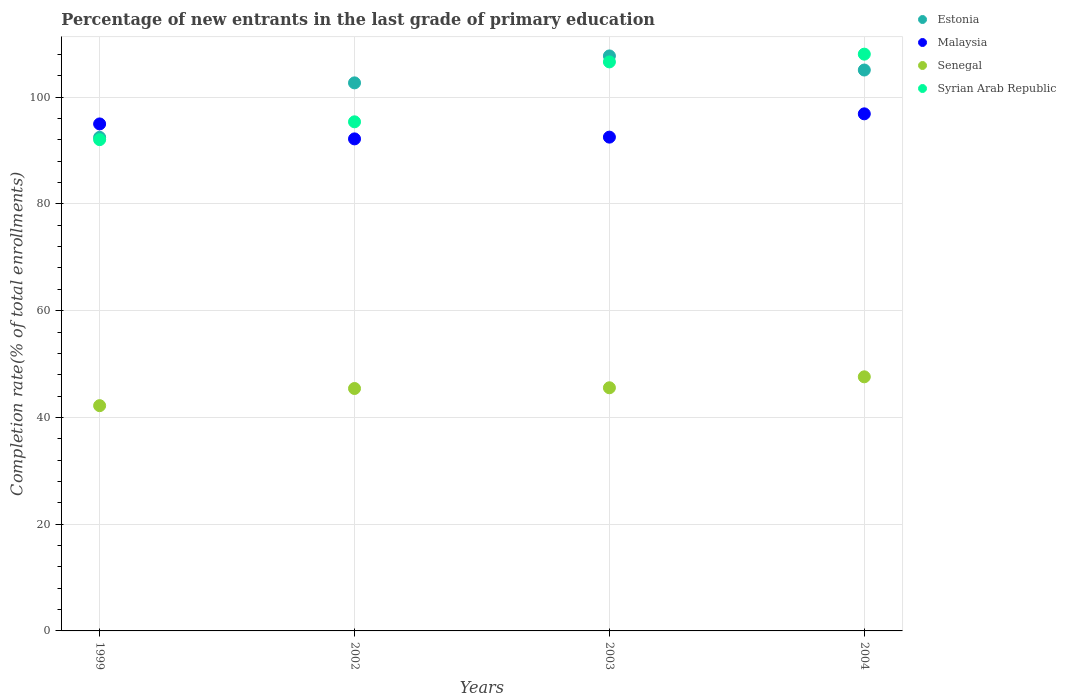Is the number of dotlines equal to the number of legend labels?
Ensure brevity in your answer.  Yes. What is the percentage of new entrants in Senegal in 2004?
Keep it short and to the point. 47.61. Across all years, what is the maximum percentage of new entrants in Estonia?
Your answer should be compact. 107.72. Across all years, what is the minimum percentage of new entrants in Senegal?
Offer a terse response. 42.2. In which year was the percentage of new entrants in Syrian Arab Republic maximum?
Give a very brief answer. 2004. What is the total percentage of new entrants in Syrian Arab Republic in the graph?
Provide a succinct answer. 402.07. What is the difference between the percentage of new entrants in Malaysia in 2002 and that in 2003?
Ensure brevity in your answer.  -0.33. What is the difference between the percentage of new entrants in Malaysia in 2002 and the percentage of new entrants in Estonia in 1999?
Offer a terse response. -0.29. What is the average percentage of new entrants in Senegal per year?
Provide a short and direct response. 45.19. In the year 2003, what is the difference between the percentage of new entrants in Senegal and percentage of new entrants in Malaysia?
Your answer should be compact. -46.95. What is the ratio of the percentage of new entrants in Estonia in 1999 to that in 2002?
Offer a terse response. 0.9. What is the difference between the highest and the second highest percentage of new entrants in Syrian Arab Republic?
Your response must be concise. 1.45. What is the difference between the highest and the lowest percentage of new entrants in Senegal?
Your response must be concise. 5.4. In how many years, is the percentage of new entrants in Senegal greater than the average percentage of new entrants in Senegal taken over all years?
Make the answer very short. 3. Is it the case that in every year, the sum of the percentage of new entrants in Syrian Arab Republic and percentage of new entrants in Malaysia  is greater than the sum of percentage of new entrants in Senegal and percentage of new entrants in Estonia?
Your answer should be compact. No. Is it the case that in every year, the sum of the percentage of new entrants in Malaysia and percentage of new entrants in Syrian Arab Republic  is greater than the percentage of new entrants in Estonia?
Your answer should be very brief. Yes. How many dotlines are there?
Your answer should be very brief. 4. What is the difference between two consecutive major ticks on the Y-axis?
Offer a very short reply. 20. Are the values on the major ticks of Y-axis written in scientific E-notation?
Ensure brevity in your answer.  No. Where does the legend appear in the graph?
Offer a very short reply. Top right. How many legend labels are there?
Provide a short and direct response. 4. What is the title of the graph?
Your answer should be compact. Percentage of new entrants in the last grade of primary education. What is the label or title of the Y-axis?
Your answer should be very brief. Completion rate(% of total enrollments). What is the Completion rate(% of total enrollments) in Estonia in 1999?
Keep it short and to the point. 92.47. What is the Completion rate(% of total enrollments) of Malaysia in 1999?
Provide a short and direct response. 94.98. What is the Completion rate(% of total enrollments) of Senegal in 1999?
Offer a very short reply. 42.2. What is the Completion rate(% of total enrollments) in Syrian Arab Republic in 1999?
Your response must be concise. 92.04. What is the Completion rate(% of total enrollments) in Estonia in 2002?
Give a very brief answer. 102.67. What is the Completion rate(% of total enrollments) of Malaysia in 2002?
Keep it short and to the point. 92.18. What is the Completion rate(% of total enrollments) of Senegal in 2002?
Your answer should be very brief. 45.42. What is the Completion rate(% of total enrollments) of Syrian Arab Republic in 2002?
Provide a succinct answer. 95.38. What is the Completion rate(% of total enrollments) of Estonia in 2003?
Provide a succinct answer. 107.72. What is the Completion rate(% of total enrollments) in Malaysia in 2003?
Provide a succinct answer. 92.51. What is the Completion rate(% of total enrollments) of Senegal in 2003?
Ensure brevity in your answer.  45.55. What is the Completion rate(% of total enrollments) in Syrian Arab Republic in 2003?
Your answer should be compact. 106.6. What is the Completion rate(% of total enrollments) of Estonia in 2004?
Make the answer very short. 105.08. What is the Completion rate(% of total enrollments) in Malaysia in 2004?
Offer a very short reply. 96.87. What is the Completion rate(% of total enrollments) of Senegal in 2004?
Your answer should be very brief. 47.61. What is the Completion rate(% of total enrollments) in Syrian Arab Republic in 2004?
Offer a very short reply. 108.05. Across all years, what is the maximum Completion rate(% of total enrollments) in Estonia?
Ensure brevity in your answer.  107.72. Across all years, what is the maximum Completion rate(% of total enrollments) of Malaysia?
Ensure brevity in your answer.  96.87. Across all years, what is the maximum Completion rate(% of total enrollments) of Senegal?
Give a very brief answer. 47.61. Across all years, what is the maximum Completion rate(% of total enrollments) of Syrian Arab Republic?
Keep it short and to the point. 108.05. Across all years, what is the minimum Completion rate(% of total enrollments) of Estonia?
Give a very brief answer. 92.47. Across all years, what is the minimum Completion rate(% of total enrollments) in Malaysia?
Offer a very short reply. 92.18. Across all years, what is the minimum Completion rate(% of total enrollments) in Senegal?
Your answer should be compact. 42.2. Across all years, what is the minimum Completion rate(% of total enrollments) in Syrian Arab Republic?
Make the answer very short. 92.04. What is the total Completion rate(% of total enrollments) of Estonia in the graph?
Keep it short and to the point. 407.94. What is the total Completion rate(% of total enrollments) in Malaysia in the graph?
Offer a very short reply. 376.54. What is the total Completion rate(% of total enrollments) in Senegal in the graph?
Offer a very short reply. 180.77. What is the total Completion rate(% of total enrollments) of Syrian Arab Republic in the graph?
Your answer should be very brief. 402.07. What is the difference between the Completion rate(% of total enrollments) of Estonia in 1999 and that in 2002?
Ensure brevity in your answer.  -10.21. What is the difference between the Completion rate(% of total enrollments) of Malaysia in 1999 and that in 2002?
Keep it short and to the point. 2.8. What is the difference between the Completion rate(% of total enrollments) in Senegal in 1999 and that in 2002?
Offer a very short reply. -3.22. What is the difference between the Completion rate(% of total enrollments) of Syrian Arab Republic in 1999 and that in 2002?
Give a very brief answer. -3.34. What is the difference between the Completion rate(% of total enrollments) in Estonia in 1999 and that in 2003?
Your answer should be compact. -15.25. What is the difference between the Completion rate(% of total enrollments) of Malaysia in 1999 and that in 2003?
Your answer should be very brief. 2.47. What is the difference between the Completion rate(% of total enrollments) in Senegal in 1999 and that in 2003?
Your response must be concise. -3.35. What is the difference between the Completion rate(% of total enrollments) in Syrian Arab Republic in 1999 and that in 2003?
Provide a succinct answer. -14.56. What is the difference between the Completion rate(% of total enrollments) of Estonia in 1999 and that in 2004?
Your response must be concise. -12.61. What is the difference between the Completion rate(% of total enrollments) in Malaysia in 1999 and that in 2004?
Provide a short and direct response. -1.89. What is the difference between the Completion rate(% of total enrollments) in Senegal in 1999 and that in 2004?
Your answer should be very brief. -5.4. What is the difference between the Completion rate(% of total enrollments) in Syrian Arab Republic in 1999 and that in 2004?
Your answer should be very brief. -16.02. What is the difference between the Completion rate(% of total enrollments) in Estonia in 2002 and that in 2003?
Provide a short and direct response. -5.05. What is the difference between the Completion rate(% of total enrollments) in Malaysia in 2002 and that in 2003?
Make the answer very short. -0.33. What is the difference between the Completion rate(% of total enrollments) in Senegal in 2002 and that in 2003?
Keep it short and to the point. -0.14. What is the difference between the Completion rate(% of total enrollments) of Syrian Arab Republic in 2002 and that in 2003?
Keep it short and to the point. -11.22. What is the difference between the Completion rate(% of total enrollments) of Estonia in 2002 and that in 2004?
Your response must be concise. -2.41. What is the difference between the Completion rate(% of total enrollments) of Malaysia in 2002 and that in 2004?
Provide a succinct answer. -4.69. What is the difference between the Completion rate(% of total enrollments) of Senegal in 2002 and that in 2004?
Keep it short and to the point. -2.19. What is the difference between the Completion rate(% of total enrollments) in Syrian Arab Republic in 2002 and that in 2004?
Make the answer very short. -12.68. What is the difference between the Completion rate(% of total enrollments) of Estonia in 2003 and that in 2004?
Give a very brief answer. 2.64. What is the difference between the Completion rate(% of total enrollments) of Malaysia in 2003 and that in 2004?
Provide a short and direct response. -4.36. What is the difference between the Completion rate(% of total enrollments) in Senegal in 2003 and that in 2004?
Make the answer very short. -2.05. What is the difference between the Completion rate(% of total enrollments) in Syrian Arab Republic in 2003 and that in 2004?
Your answer should be compact. -1.45. What is the difference between the Completion rate(% of total enrollments) of Estonia in 1999 and the Completion rate(% of total enrollments) of Malaysia in 2002?
Your response must be concise. 0.29. What is the difference between the Completion rate(% of total enrollments) in Estonia in 1999 and the Completion rate(% of total enrollments) in Senegal in 2002?
Your answer should be compact. 47.05. What is the difference between the Completion rate(% of total enrollments) of Estonia in 1999 and the Completion rate(% of total enrollments) of Syrian Arab Republic in 2002?
Offer a terse response. -2.91. What is the difference between the Completion rate(% of total enrollments) of Malaysia in 1999 and the Completion rate(% of total enrollments) of Senegal in 2002?
Make the answer very short. 49.57. What is the difference between the Completion rate(% of total enrollments) in Malaysia in 1999 and the Completion rate(% of total enrollments) in Syrian Arab Republic in 2002?
Keep it short and to the point. -0.4. What is the difference between the Completion rate(% of total enrollments) of Senegal in 1999 and the Completion rate(% of total enrollments) of Syrian Arab Republic in 2002?
Provide a succinct answer. -53.18. What is the difference between the Completion rate(% of total enrollments) in Estonia in 1999 and the Completion rate(% of total enrollments) in Malaysia in 2003?
Offer a terse response. -0.04. What is the difference between the Completion rate(% of total enrollments) of Estonia in 1999 and the Completion rate(% of total enrollments) of Senegal in 2003?
Your answer should be compact. 46.91. What is the difference between the Completion rate(% of total enrollments) of Estonia in 1999 and the Completion rate(% of total enrollments) of Syrian Arab Republic in 2003?
Offer a very short reply. -14.13. What is the difference between the Completion rate(% of total enrollments) in Malaysia in 1999 and the Completion rate(% of total enrollments) in Senegal in 2003?
Ensure brevity in your answer.  49.43. What is the difference between the Completion rate(% of total enrollments) of Malaysia in 1999 and the Completion rate(% of total enrollments) of Syrian Arab Republic in 2003?
Provide a succinct answer. -11.62. What is the difference between the Completion rate(% of total enrollments) of Senegal in 1999 and the Completion rate(% of total enrollments) of Syrian Arab Republic in 2003?
Ensure brevity in your answer.  -64.4. What is the difference between the Completion rate(% of total enrollments) of Estonia in 1999 and the Completion rate(% of total enrollments) of Malaysia in 2004?
Keep it short and to the point. -4.4. What is the difference between the Completion rate(% of total enrollments) of Estonia in 1999 and the Completion rate(% of total enrollments) of Senegal in 2004?
Give a very brief answer. 44.86. What is the difference between the Completion rate(% of total enrollments) in Estonia in 1999 and the Completion rate(% of total enrollments) in Syrian Arab Republic in 2004?
Your response must be concise. -15.59. What is the difference between the Completion rate(% of total enrollments) of Malaysia in 1999 and the Completion rate(% of total enrollments) of Senegal in 2004?
Offer a terse response. 47.38. What is the difference between the Completion rate(% of total enrollments) of Malaysia in 1999 and the Completion rate(% of total enrollments) of Syrian Arab Republic in 2004?
Your answer should be compact. -13.07. What is the difference between the Completion rate(% of total enrollments) of Senegal in 1999 and the Completion rate(% of total enrollments) of Syrian Arab Republic in 2004?
Ensure brevity in your answer.  -65.85. What is the difference between the Completion rate(% of total enrollments) of Estonia in 2002 and the Completion rate(% of total enrollments) of Malaysia in 2003?
Your response must be concise. 10.17. What is the difference between the Completion rate(% of total enrollments) in Estonia in 2002 and the Completion rate(% of total enrollments) in Senegal in 2003?
Your response must be concise. 57.12. What is the difference between the Completion rate(% of total enrollments) of Estonia in 2002 and the Completion rate(% of total enrollments) of Syrian Arab Republic in 2003?
Ensure brevity in your answer.  -3.93. What is the difference between the Completion rate(% of total enrollments) of Malaysia in 2002 and the Completion rate(% of total enrollments) of Senegal in 2003?
Your answer should be very brief. 46.63. What is the difference between the Completion rate(% of total enrollments) of Malaysia in 2002 and the Completion rate(% of total enrollments) of Syrian Arab Republic in 2003?
Ensure brevity in your answer.  -14.42. What is the difference between the Completion rate(% of total enrollments) in Senegal in 2002 and the Completion rate(% of total enrollments) in Syrian Arab Republic in 2003?
Keep it short and to the point. -61.18. What is the difference between the Completion rate(% of total enrollments) of Estonia in 2002 and the Completion rate(% of total enrollments) of Malaysia in 2004?
Provide a short and direct response. 5.8. What is the difference between the Completion rate(% of total enrollments) of Estonia in 2002 and the Completion rate(% of total enrollments) of Senegal in 2004?
Your answer should be compact. 55.07. What is the difference between the Completion rate(% of total enrollments) in Estonia in 2002 and the Completion rate(% of total enrollments) in Syrian Arab Republic in 2004?
Your answer should be compact. -5.38. What is the difference between the Completion rate(% of total enrollments) of Malaysia in 2002 and the Completion rate(% of total enrollments) of Senegal in 2004?
Give a very brief answer. 44.57. What is the difference between the Completion rate(% of total enrollments) in Malaysia in 2002 and the Completion rate(% of total enrollments) in Syrian Arab Republic in 2004?
Offer a very short reply. -15.87. What is the difference between the Completion rate(% of total enrollments) of Senegal in 2002 and the Completion rate(% of total enrollments) of Syrian Arab Republic in 2004?
Keep it short and to the point. -62.64. What is the difference between the Completion rate(% of total enrollments) of Estonia in 2003 and the Completion rate(% of total enrollments) of Malaysia in 2004?
Your answer should be very brief. 10.85. What is the difference between the Completion rate(% of total enrollments) in Estonia in 2003 and the Completion rate(% of total enrollments) in Senegal in 2004?
Your answer should be compact. 60.11. What is the difference between the Completion rate(% of total enrollments) in Estonia in 2003 and the Completion rate(% of total enrollments) in Syrian Arab Republic in 2004?
Provide a short and direct response. -0.33. What is the difference between the Completion rate(% of total enrollments) of Malaysia in 2003 and the Completion rate(% of total enrollments) of Senegal in 2004?
Give a very brief answer. 44.9. What is the difference between the Completion rate(% of total enrollments) of Malaysia in 2003 and the Completion rate(% of total enrollments) of Syrian Arab Republic in 2004?
Your answer should be very brief. -15.55. What is the difference between the Completion rate(% of total enrollments) in Senegal in 2003 and the Completion rate(% of total enrollments) in Syrian Arab Republic in 2004?
Your response must be concise. -62.5. What is the average Completion rate(% of total enrollments) in Estonia per year?
Make the answer very short. 101.99. What is the average Completion rate(% of total enrollments) in Malaysia per year?
Keep it short and to the point. 94.13. What is the average Completion rate(% of total enrollments) of Senegal per year?
Provide a short and direct response. 45.19. What is the average Completion rate(% of total enrollments) in Syrian Arab Republic per year?
Provide a short and direct response. 100.52. In the year 1999, what is the difference between the Completion rate(% of total enrollments) in Estonia and Completion rate(% of total enrollments) in Malaysia?
Your answer should be compact. -2.51. In the year 1999, what is the difference between the Completion rate(% of total enrollments) in Estonia and Completion rate(% of total enrollments) in Senegal?
Make the answer very short. 50.27. In the year 1999, what is the difference between the Completion rate(% of total enrollments) of Estonia and Completion rate(% of total enrollments) of Syrian Arab Republic?
Provide a short and direct response. 0.43. In the year 1999, what is the difference between the Completion rate(% of total enrollments) of Malaysia and Completion rate(% of total enrollments) of Senegal?
Provide a succinct answer. 52.78. In the year 1999, what is the difference between the Completion rate(% of total enrollments) of Malaysia and Completion rate(% of total enrollments) of Syrian Arab Republic?
Keep it short and to the point. 2.94. In the year 1999, what is the difference between the Completion rate(% of total enrollments) of Senegal and Completion rate(% of total enrollments) of Syrian Arab Republic?
Give a very brief answer. -49.84. In the year 2002, what is the difference between the Completion rate(% of total enrollments) of Estonia and Completion rate(% of total enrollments) of Malaysia?
Provide a short and direct response. 10.49. In the year 2002, what is the difference between the Completion rate(% of total enrollments) in Estonia and Completion rate(% of total enrollments) in Senegal?
Offer a very short reply. 57.26. In the year 2002, what is the difference between the Completion rate(% of total enrollments) in Estonia and Completion rate(% of total enrollments) in Syrian Arab Republic?
Provide a succinct answer. 7.3. In the year 2002, what is the difference between the Completion rate(% of total enrollments) of Malaysia and Completion rate(% of total enrollments) of Senegal?
Your answer should be very brief. 46.76. In the year 2002, what is the difference between the Completion rate(% of total enrollments) in Malaysia and Completion rate(% of total enrollments) in Syrian Arab Republic?
Keep it short and to the point. -3.2. In the year 2002, what is the difference between the Completion rate(% of total enrollments) in Senegal and Completion rate(% of total enrollments) in Syrian Arab Republic?
Give a very brief answer. -49.96. In the year 2003, what is the difference between the Completion rate(% of total enrollments) in Estonia and Completion rate(% of total enrollments) in Malaysia?
Give a very brief answer. 15.21. In the year 2003, what is the difference between the Completion rate(% of total enrollments) of Estonia and Completion rate(% of total enrollments) of Senegal?
Ensure brevity in your answer.  62.17. In the year 2003, what is the difference between the Completion rate(% of total enrollments) of Estonia and Completion rate(% of total enrollments) of Syrian Arab Republic?
Your answer should be very brief. 1.12. In the year 2003, what is the difference between the Completion rate(% of total enrollments) in Malaysia and Completion rate(% of total enrollments) in Senegal?
Your answer should be compact. 46.95. In the year 2003, what is the difference between the Completion rate(% of total enrollments) of Malaysia and Completion rate(% of total enrollments) of Syrian Arab Republic?
Your answer should be very brief. -14.09. In the year 2003, what is the difference between the Completion rate(% of total enrollments) in Senegal and Completion rate(% of total enrollments) in Syrian Arab Republic?
Ensure brevity in your answer.  -61.05. In the year 2004, what is the difference between the Completion rate(% of total enrollments) in Estonia and Completion rate(% of total enrollments) in Malaysia?
Keep it short and to the point. 8.21. In the year 2004, what is the difference between the Completion rate(% of total enrollments) in Estonia and Completion rate(% of total enrollments) in Senegal?
Your answer should be compact. 57.48. In the year 2004, what is the difference between the Completion rate(% of total enrollments) in Estonia and Completion rate(% of total enrollments) in Syrian Arab Republic?
Give a very brief answer. -2.97. In the year 2004, what is the difference between the Completion rate(% of total enrollments) in Malaysia and Completion rate(% of total enrollments) in Senegal?
Provide a short and direct response. 49.27. In the year 2004, what is the difference between the Completion rate(% of total enrollments) of Malaysia and Completion rate(% of total enrollments) of Syrian Arab Republic?
Provide a succinct answer. -11.18. In the year 2004, what is the difference between the Completion rate(% of total enrollments) in Senegal and Completion rate(% of total enrollments) in Syrian Arab Republic?
Give a very brief answer. -60.45. What is the ratio of the Completion rate(% of total enrollments) in Estonia in 1999 to that in 2002?
Keep it short and to the point. 0.9. What is the ratio of the Completion rate(% of total enrollments) in Malaysia in 1999 to that in 2002?
Offer a terse response. 1.03. What is the ratio of the Completion rate(% of total enrollments) of Senegal in 1999 to that in 2002?
Provide a succinct answer. 0.93. What is the ratio of the Completion rate(% of total enrollments) in Syrian Arab Republic in 1999 to that in 2002?
Offer a very short reply. 0.96. What is the ratio of the Completion rate(% of total enrollments) in Estonia in 1999 to that in 2003?
Provide a short and direct response. 0.86. What is the ratio of the Completion rate(% of total enrollments) of Malaysia in 1999 to that in 2003?
Give a very brief answer. 1.03. What is the ratio of the Completion rate(% of total enrollments) of Senegal in 1999 to that in 2003?
Give a very brief answer. 0.93. What is the ratio of the Completion rate(% of total enrollments) of Syrian Arab Republic in 1999 to that in 2003?
Your response must be concise. 0.86. What is the ratio of the Completion rate(% of total enrollments) of Estonia in 1999 to that in 2004?
Keep it short and to the point. 0.88. What is the ratio of the Completion rate(% of total enrollments) of Malaysia in 1999 to that in 2004?
Provide a short and direct response. 0.98. What is the ratio of the Completion rate(% of total enrollments) of Senegal in 1999 to that in 2004?
Offer a very short reply. 0.89. What is the ratio of the Completion rate(% of total enrollments) of Syrian Arab Republic in 1999 to that in 2004?
Your response must be concise. 0.85. What is the ratio of the Completion rate(% of total enrollments) in Estonia in 2002 to that in 2003?
Give a very brief answer. 0.95. What is the ratio of the Completion rate(% of total enrollments) of Malaysia in 2002 to that in 2003?
Your response must be concise. 1. What is the ratio of the Completion rate(% of total enrollments) of Senegal in 2002 to that in 2003?
Your response must be concise. 1. What is the ratio of the Completion rate(% of total enrollments) in Syrian Arab Republic in 2002 to that in 2003?
Offer a very short reply. 0.89. What is the ratio of the Completion rate(% of total enrollments) in Estonia in 2002 to that in 2004?
Provide a succinct answer. 0.98. What is the ratio of the Completion rate(% of total enrollments) of Malaysia in 2002 to that in 2004?
Ensure brevity in your answer.  0.95. What is the ratio of the Completion rate(% of total enrollments) in Senegal in 2002 to that in 2004?
Your answer should be compact. 0.95. What is the ratio of the Completion rate(% of total enrollments) of Syrian Arab Republic in 2002 to that in 2004?
Make the answer very short. 0.88. What is the ratio of the Completion rate(% of total enrollments) of Estonia in 2003 to that in 2004?
Offer a terse response. 1.03. What is the ratio of the Completion rate(% of total enrollments) of Malaysia in 2003 to that in 2004?
Ensure brevity in your answer.  0.95. What is the ratio of the Completion rate(% of total enrollments) of Senegal in 2003 to that in 2004?
Offer a terse response. 0.96. What is the ratio of the Completion rate(% of total enrollments) of Syrian Arab Republic in 2003 to that in 2004?
Provide a short and direct response. 0.99. What is the difference between the highest and the second highest Completion rate(% of total enrollments) in Estonia?
Your response must be concise. 2.64. What is the difference between the highest and the second highest Completion rate(% of total enrollments) in Malaysia?
Make the answer very short. 1.89. What is the difference between the highest and the second highest Completion rate(% of total enrollments) in Senegal?
Provide a short and direct response. 2.05. What is the difference between the highest and the second highest Completion rate(% of total enrollments) in Syrian Arab Republic?
Your answer should be very brief. 1.45. What is the difference between the highest and the lowest Completion rate(% of total enrollments) of Estonia?
Provide a short and direct response. 15.25. What is the difference between the highest and the lowest Completion rate(% of total enrollments) in Malaysia?
Give a very brief answer. 4.69. What is the difference between the highest and the lowest Completion rate(% of total enrollments) of Senegal?
Provide a short and direct response. 5.4. What is the difference between the highest and the lowest Completion rate(% of total enrollments) in Syrian Arab Republic?
Your answer should be very brief. 16.02. 